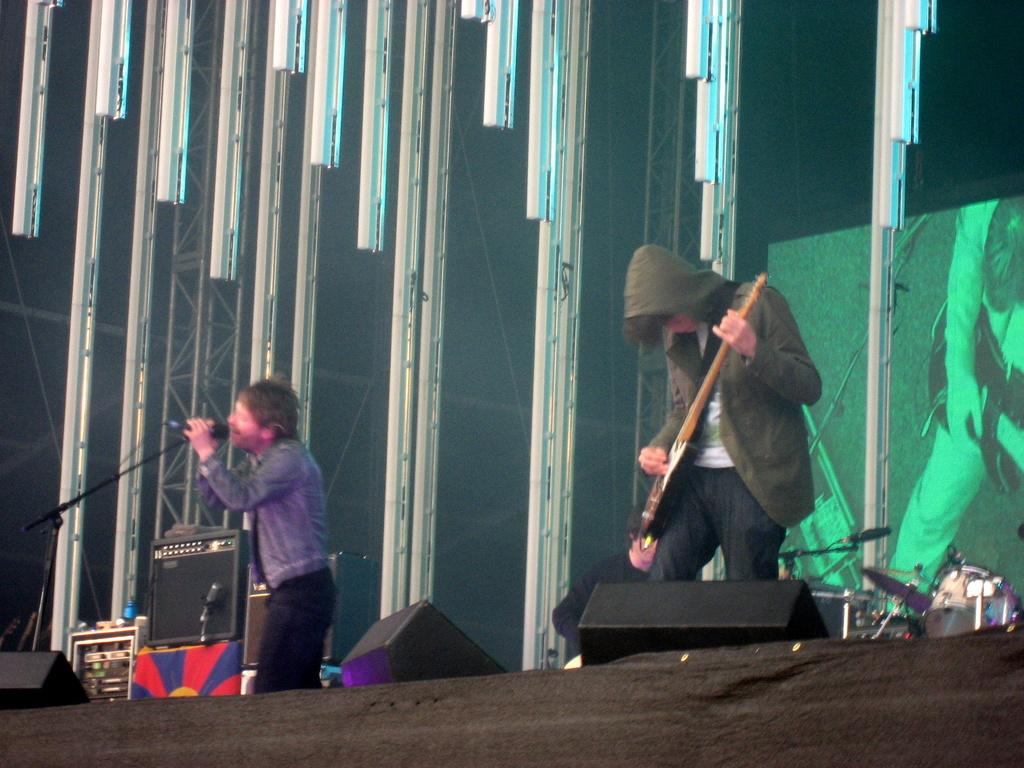What is the man in the image doing? The man in the image is singing. What is the man holding while singing? The man is holding a microphone. Are there any other musicians in the image? Yes, there is a man playing the guitar in the image. What can be seen in the background of the image? There is a screen in the background. What can be seen illuminated in the image? There is a light visible in the image. What type of vacation is the wren planning in the image? There is no wren present in the image, so it is not possible to discuss any vacation plans. 